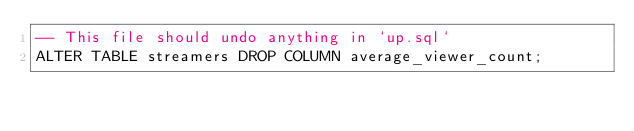Convert code to text. <code><loc_0><loc_0><loc_500><loc_500><_SQL_>-- This file should undo anything in `up.sql`
ALTER TABLE streamers DROP COLUMN average_viewer_count;
</code> 